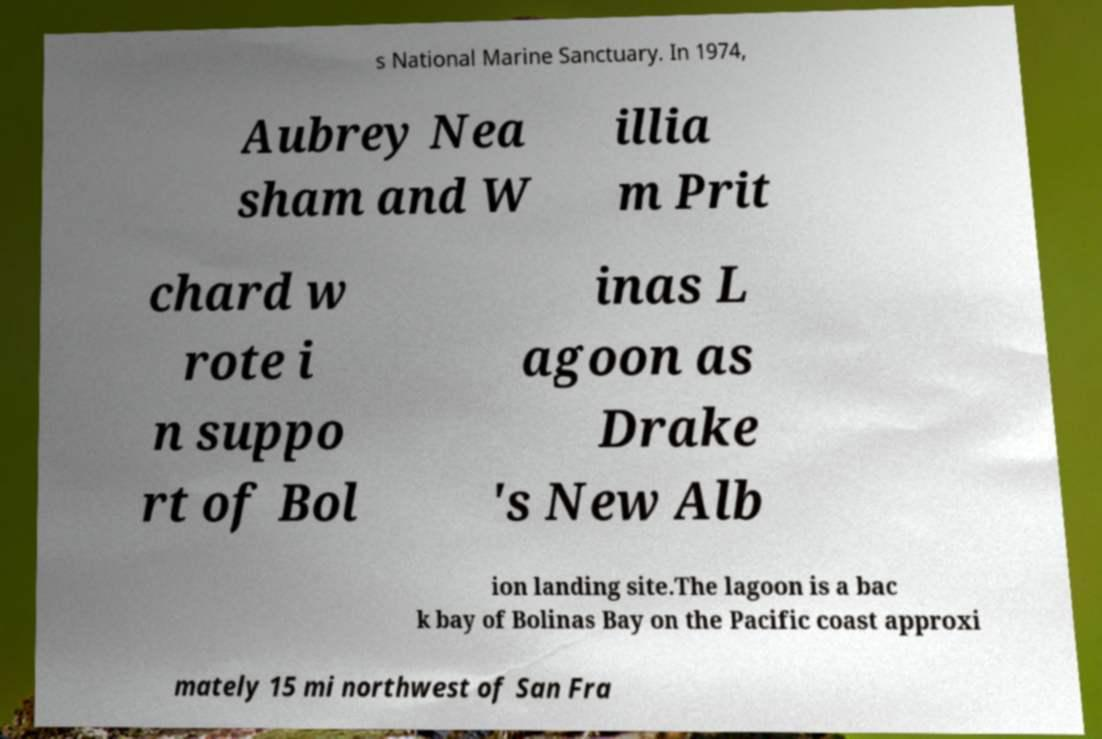For documentation purposes, I need the text within this image transcribed. Could you provide that? s National Marine Sanctuary. In 1974, Aubrey Nea sham and W illia m Prit chard w rote i n suppo rt of Bol inas L agoon as Drake 's New Alb ion landing site.The lagoon is a bac k bay of Bolinas Bay on the Pacific coast approxi mately 15 mi northwest of San Fra 